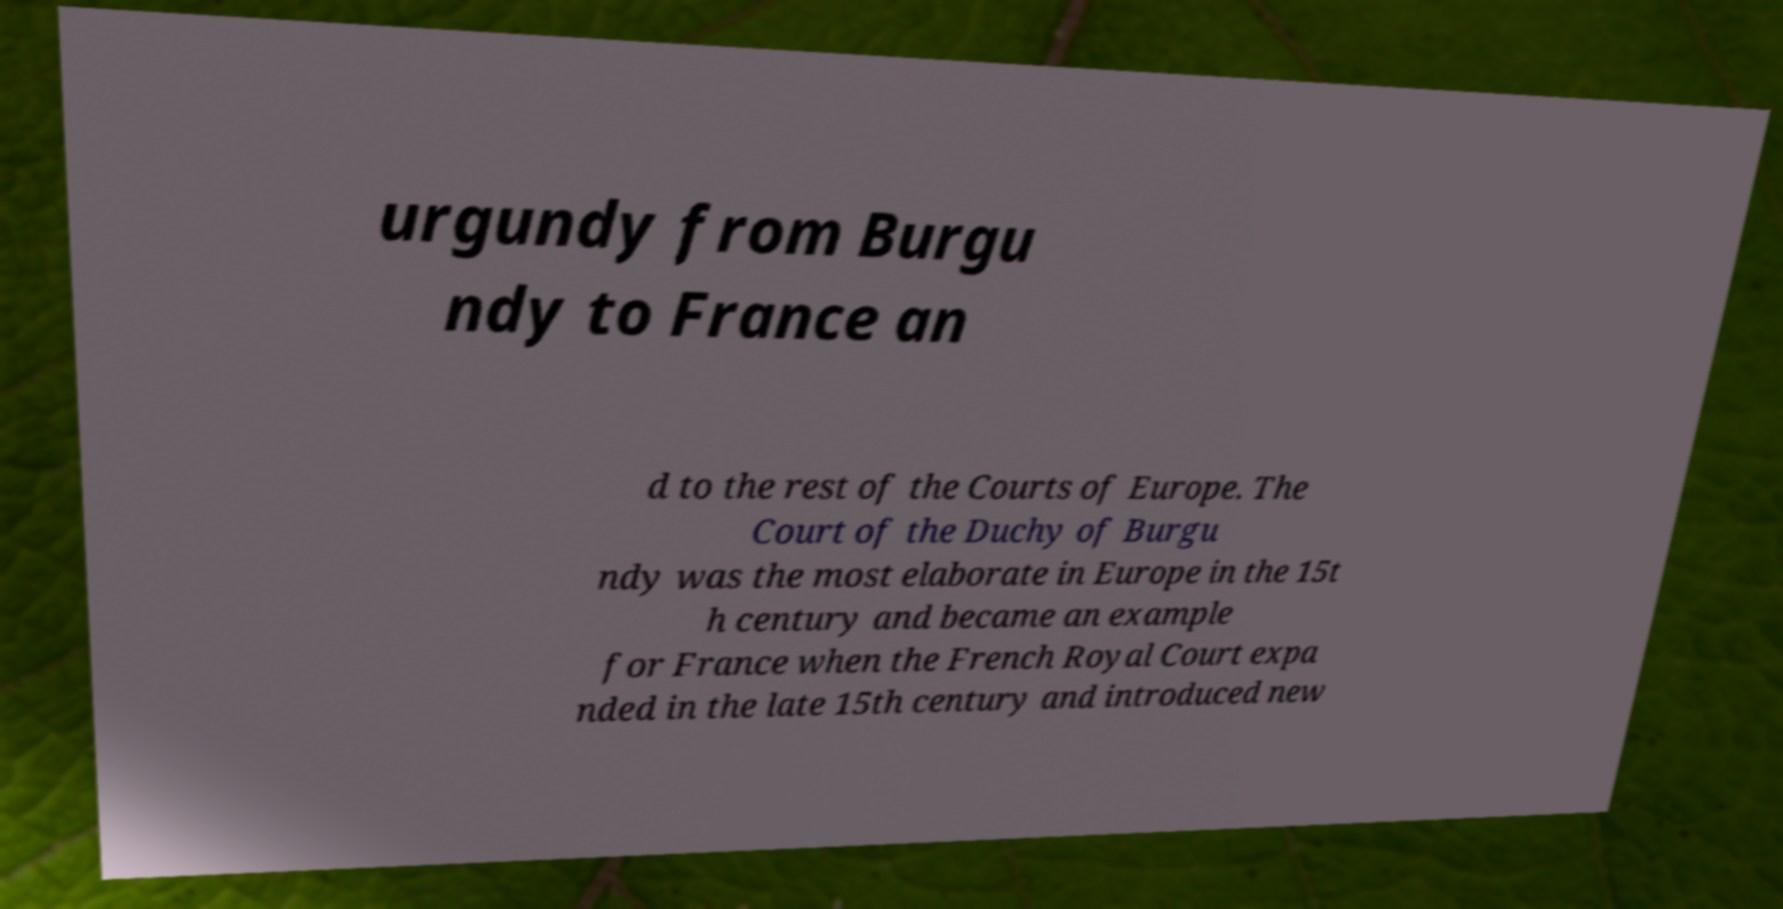Can you read and provide the text displayed in the image?This photo seems to have some interesting text. Can you extract and type it out for me? urgundy from Burgu ndy to France an d to the rest of the Courts of Europe. The Court of the Duchy of Burgu ndy was the most elaborate in Europe in the 15t h century and became an example for France when the French Royal Court expa nded in the late 15th century and introduced new 